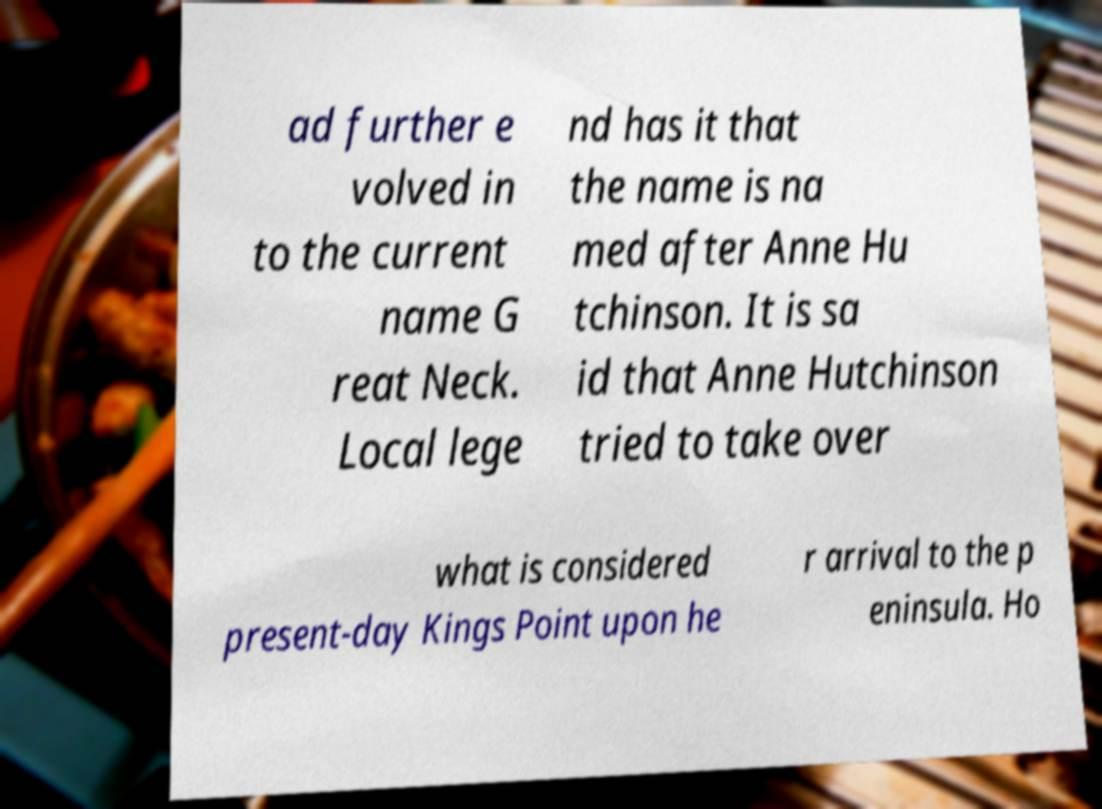Can you accurately transcribe the text from the provided image for me? ad further e volved in to the current name G reat Neck. Local lege nd has it that the name is na med after Anne Hu tchinson. It is sa id that Anne Hutchinson tried to take over what is considered present-day Kings Point upon he r arrival to the p eninsula. Ho 